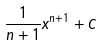<formula> <loc_0><loc_0><loc_500><loc_500>\frac { 1 } { n + 1 } x ^ { n + 1 } + C</formula> 